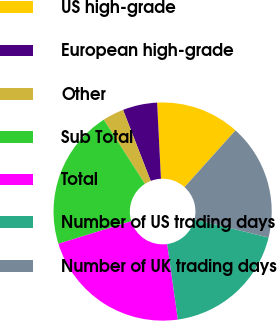Convert chart. <chart><loc_0><loc_0><loc_500><loc_500><pie_chart><fcel>US high-grade<fcel>European high-grade<fcel>Other<fcel>Sub Total<fcel>Total<fcel>Number of US trading days<fcel>Number of UK trading days<nl><fcel>12.45%<fcel>5.1%<fcel>3.16%<fcel>20.71%<fcel>22.46%<fcel>18.94%<fcel>17.19%<nl></chart> 